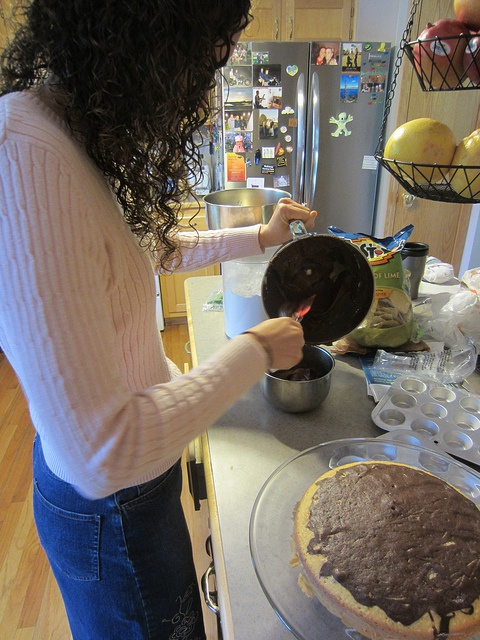Describe the objects in this image and their specific colors. I can see people in gray, black, and darkgray tones, cake in gray and black tones, refrigerator in gray, darkgray, and lightgray tones, apple in gray, maroon, black, and brown tones, and orange in gray and olive tones in this image. 